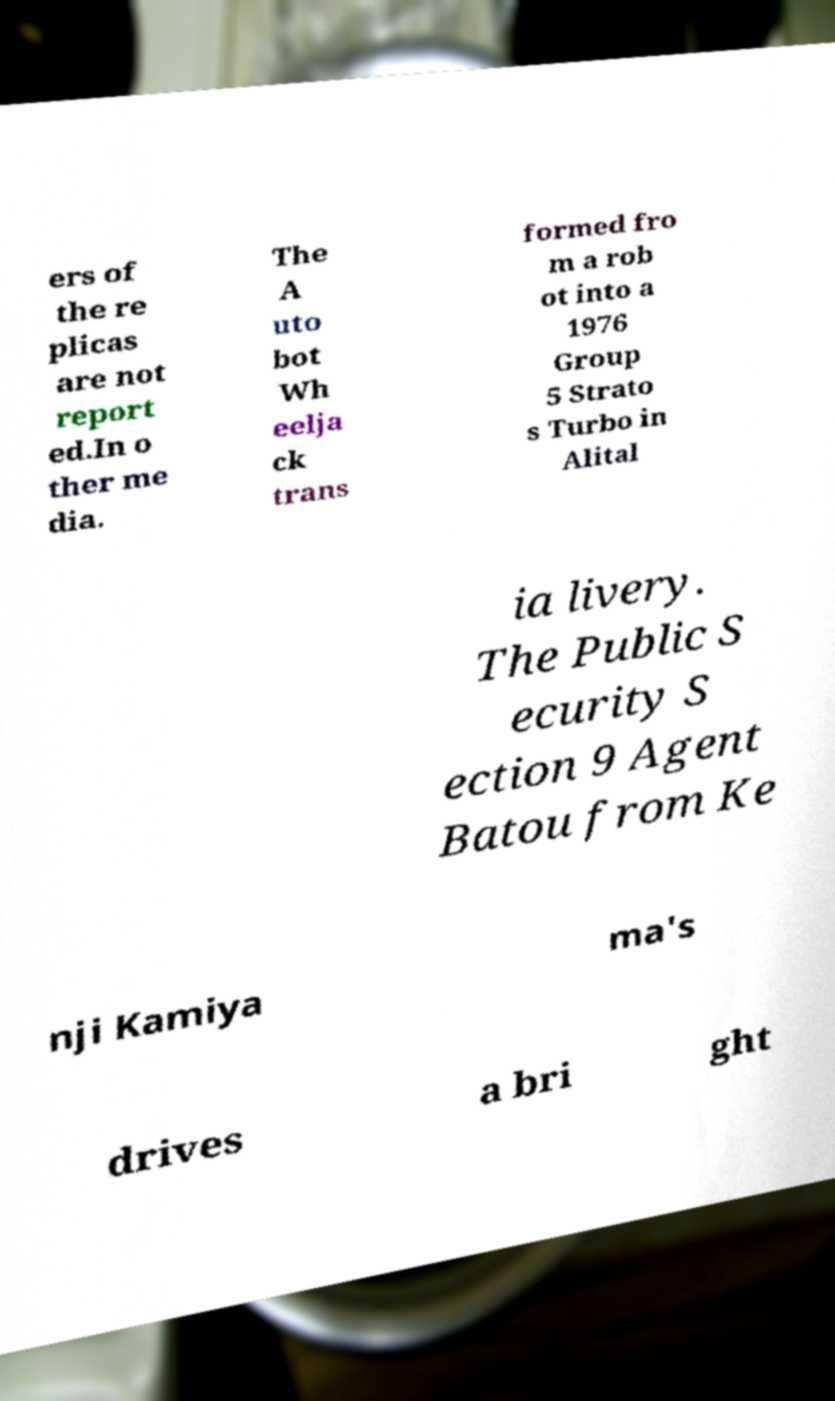There's text embedded in this image that I need extracted. Can you transcribe it verbatim? ers of the re plicas are not report ed.In o ther me dia. The A uto bot Wh eelja ck trans formed fro m a rob ot into a 1976 Group 5 Strato s Turbo in Alital ia livery. The Public S ecurity S ection 9 Agent Batou from Ke nji Kamiya ma's drives a bri ght 